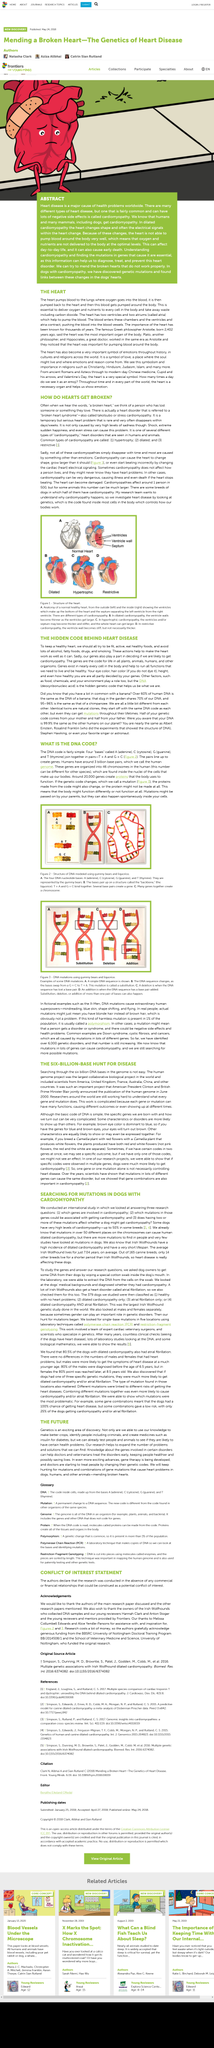Draw attention to some important aspects in this diagram. The DNA code pair of thymine and cytosine is not valid as thymine pairs with adenine, and cytosine pairs with guanine. President Clinton announced the publication of the genome. A human cell contains 46 chromosomes, which are a critical component of the cell's genetic material. Spontaneous changes in the DNA code, known as mutations, occur naturally and can have a significant impact on the structure and function of genes. In order to maintain a healthy heart, it is essential to engage in regular physical activity, consume a balanced diet that is rich in nutritious foods, and avoid excessive consumption of alcohol, unhealthy fats, drugs, and smoking. 